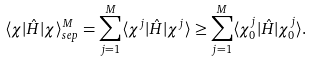<formula> <loc_0><loc_0><loc_500><loc_500>\langle \chi | \hat { H } | \chi \rangle ^ { M } _ { s e p } = \sum _ { j = 1 } ^ { M } \langle \chi ^ { j } | \hat { H } | \chi ^ { j } \rangle \geq \sum _ { j = 1 } ^ { M } \langle \chi _ { 0 } ^ { j } | \hat { H } | \chi _ { 0 } ^ { j } \rangle .</formula> 